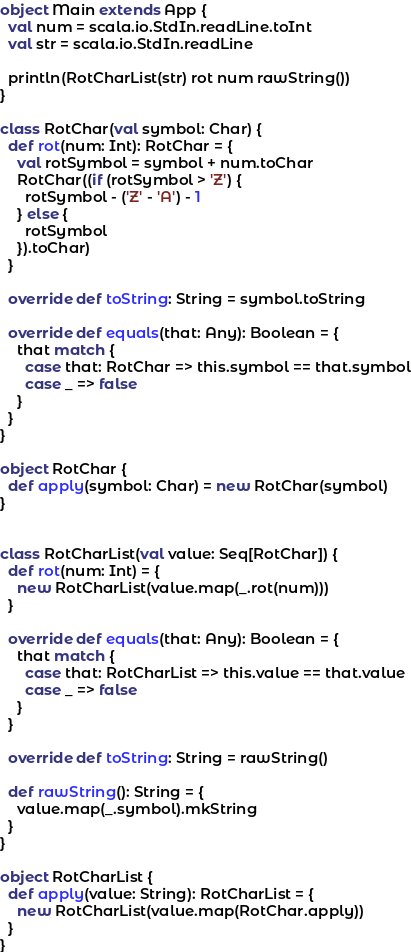<code> <loc_0><loc_0><loc_500><loc_500><_Scala_>
object Main extends App {
  val num = scala.io.StdIn.readLine.toInt
  val str = scala.io.StdIn.readLine

  println(RotCharList(str) rot num rawString())
}

class RotChar(val symbol: Char) {
  def rot(num: Int): RotChar = {
    val rotSymbol = symbol + num.toChar
    RotChar((if (rotSymbol > 'Z') {
      rotSymbol - ('Z' - 'A') - 1
    } else {
      rotSymbol
    }).toChar)
  }

  override def toString: String = symbol.toString

  override def equals(that: Any): Boolean = {
    that match {
      case that: RotChar => this.symbol == that.symbol
      case _ => false
    }
  }
}

object RotChar {
  def apply(symbol: Char) = new RotChar(symbol)
}


class RotCharList(val value: Seq[RotChar]) {
  def rot(num: Int) = {
    new RotCharList(value.map(_.rot(num)))
  }

  override def equals(that: Any): Boolean = {
    that match {
      case that: RotCharList => this.value == that.value
      case _ => false
    }
  }

  override def toString: String = rawString()

  def rawString(): String = {
    value.map(_.symbol).mkString
  }
}

object RotCharList {
  def apply(value: String): RotCharList = {
    new RotCharList(value.map(RotChar.apply))
  }
}</code> 